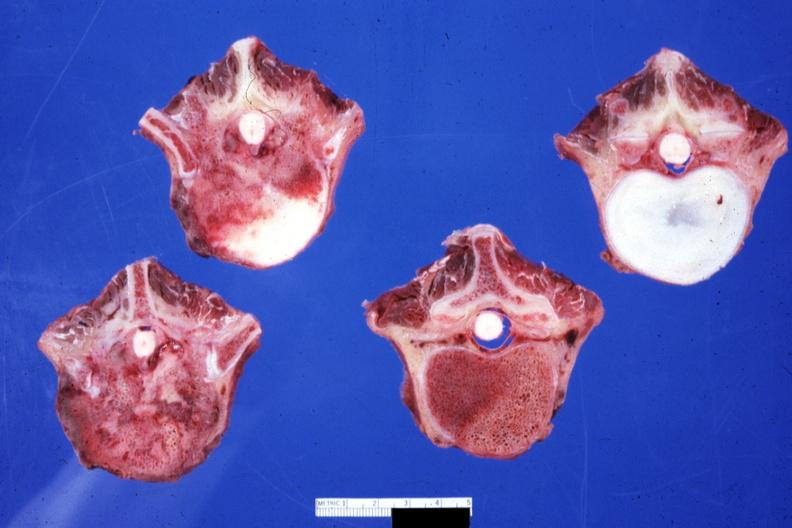s joints present?
Answer the question using a single word or phrase. Yes 